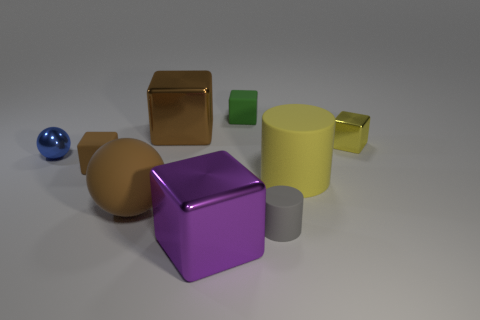How many brown cubes must be subtracted to get 1 brown cubes? 1 Subtract all green cubes. How many cubes are left? 4 Subtract all brown blocks. How many blocks are left? 3 Subtract 1 spheres. How many spheres are left? 1 Subtract all brown spheres. Subtract all brown metal cubes. How many objects are left? 7 Add 7 big purple blocks. How many big purple blocks are left? 8 Add 2 small gray blocks. How many small gray blocks exist? 2 Subtract 1 green blocks. How many objects are left? 8 Subtract all balls. How many objects are left? 7 Subtract all brown blocks. Subtract all brown spheres. How many blocks are left? 3 